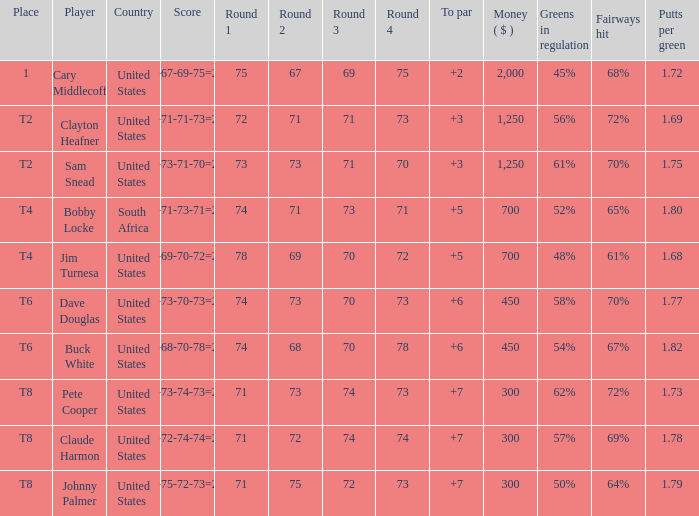What is the Johnny Palmer with a To larger than 6 Money sum? 300.0. 